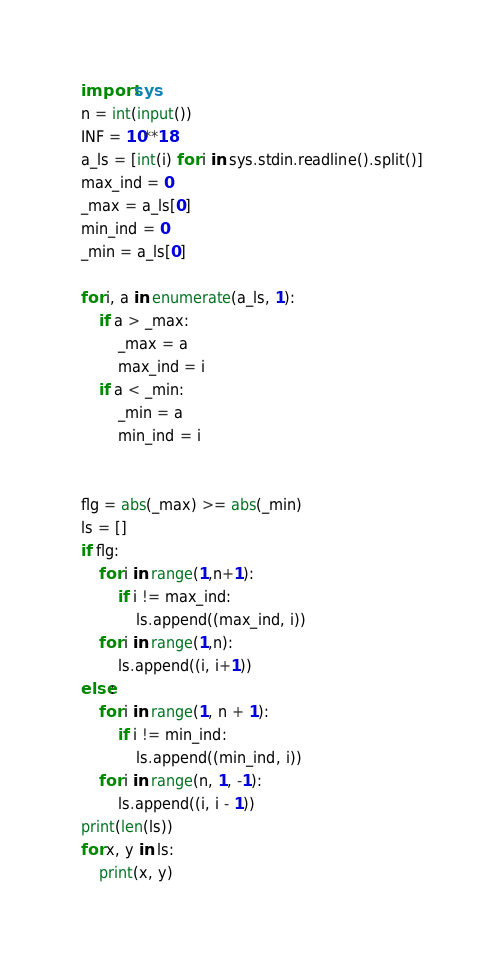<code> <loc_0><loc_0><loc_500><loc_500><_Python_>import sys
n = int(input())
INF = 10**18
a_ls = [int(i) for i in sys.stdin.readline().split()]
max_ind = 0
_max = a_ls[0]
min_ind = 0
_min = a_ls[0]

for i, a in enumerate(a_ls, 1):
    if a > _max:
        _max = a
        max_ind = i
    if a < _min:
        _min = a
        min_ind = i


flg = abs(_max) >= abs(_min)
ls = []
if flg:
    for i in range(1,n+1):
        if i != max_ind:
            ls.append((max_ind, i))
    for i in range(1,n):
        ls.append((i, i+1))
else:
    for i in range(1, n + 1):
        if i != min_ind:
            ls.append((min_ind, i))
    for i in range(n, 1, -1):
        ls.append((i, i - 1))
print(len(ls))
for x, y in ls:
    print(x, y)</code> 